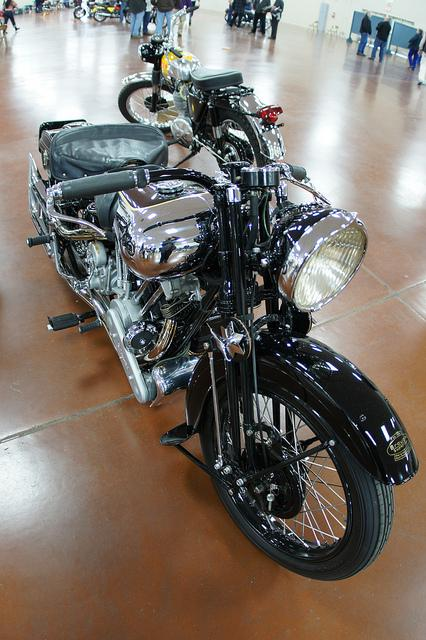What is the large glass object on the bike called?

Choices:
A) headlight
B) turn light
C) break light
D) night light headlight 